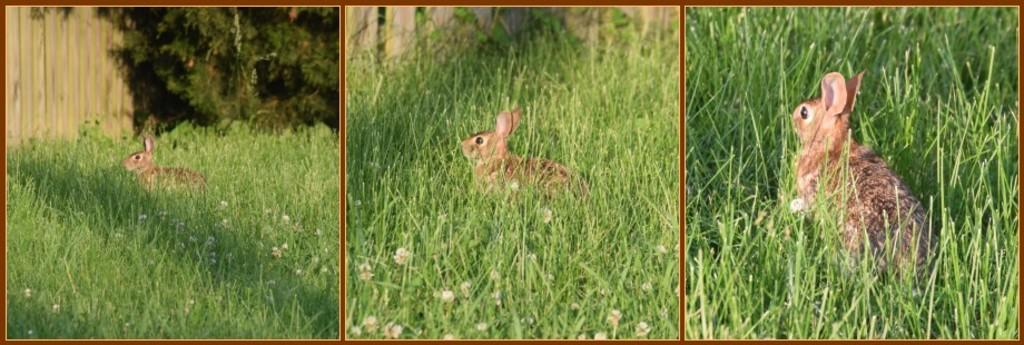What is the main feature of the image? The image contains a collage of three pictures. What can be seen in the pictures? In these pictures, there is grass visible. Are there any animals present in the pictures? Yes, there is a rabbit present in the pictures. How many girls are holding the rabbit's toes in the image? There are no girls or rabbit's toes present in the image. 